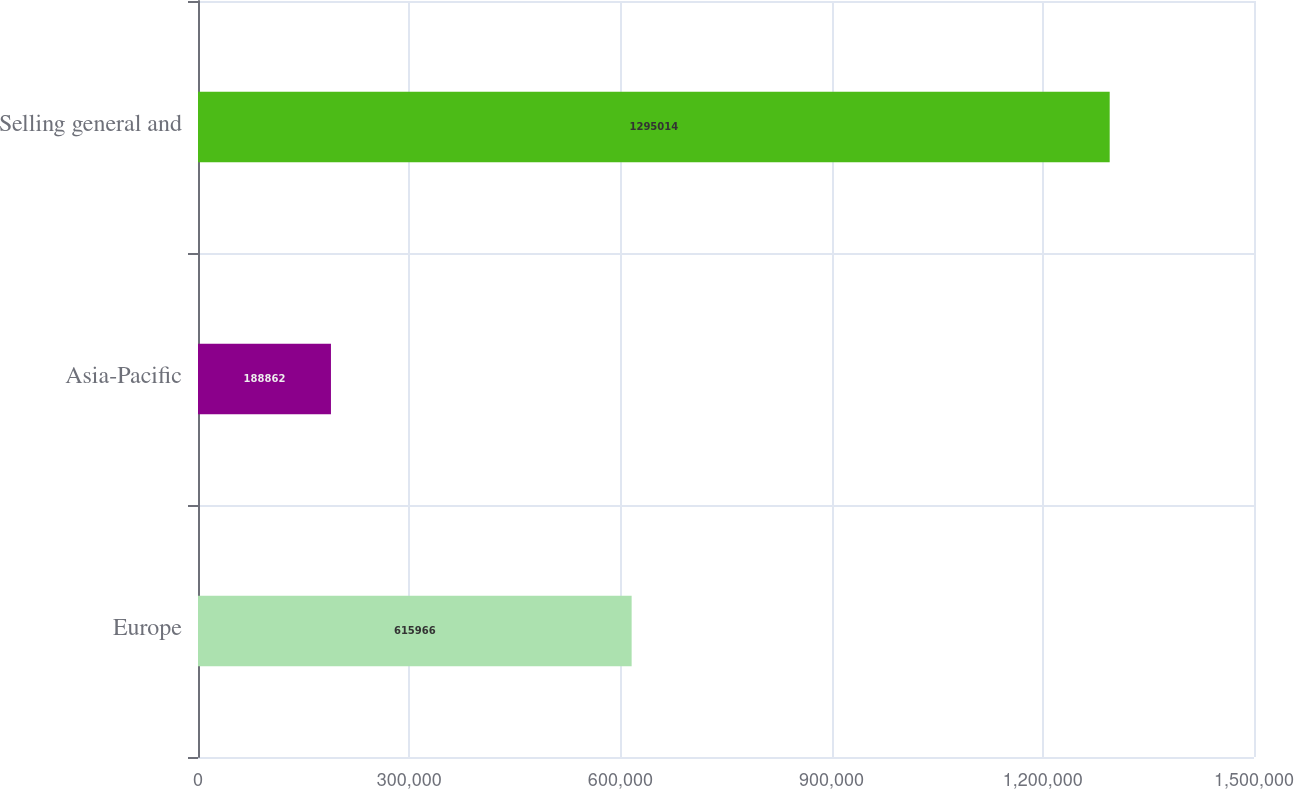Convert chart. <chart><loc_0><loc_0><loc_500><loc_500><bar_chart><fcel>Europe<fcel>Asia-Pacific<fcel>Selling general and<nl><fcel>615966<fcel>188862<fcel>1.29501e+06<nl></chart> 